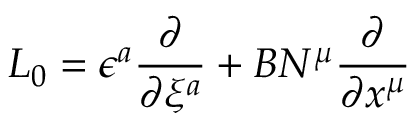Convert formula to latex. <formula><loc_0><loc_0><loc_500><loc_500>L _ { 0 } = \epsilon ^ { a } \frac { \partial } { \partial \xi ^ { a } } + B N ^ { \mu } \frac { \partial } { \partial x ^ { \mu } }</formula> 